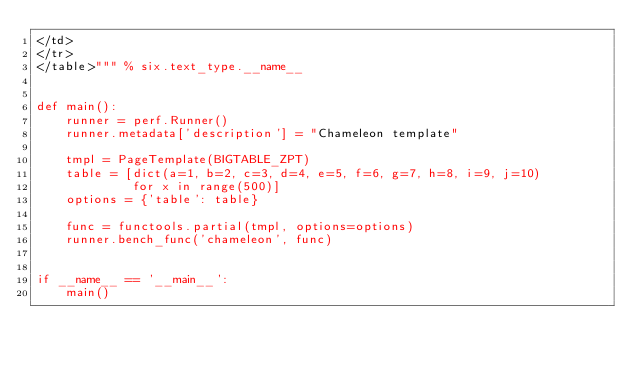Convert code to text. <code><loc_0><loc_0><loc_500><loc_500><_Python_></td>
</tr>
</table>""" % six.text_type.__name__


def main():
    runner = perf.Runner()
    runner.metadata['description'] = "Chameleon template"

    tmpl = PageTemplate(BIGTABLE_ZPT)
    table = [dict(a=1, b=2, c=3, d=4, e=5, f=6, g=7, h=8, i=9, j=10)
             for x in range(500)]
    options = {'table': table}

    func = functools.partial(tmpl, options=options)
    runner.bench_func('chameleon', func)


if __name__ == '__main__':
    main()
</code> 